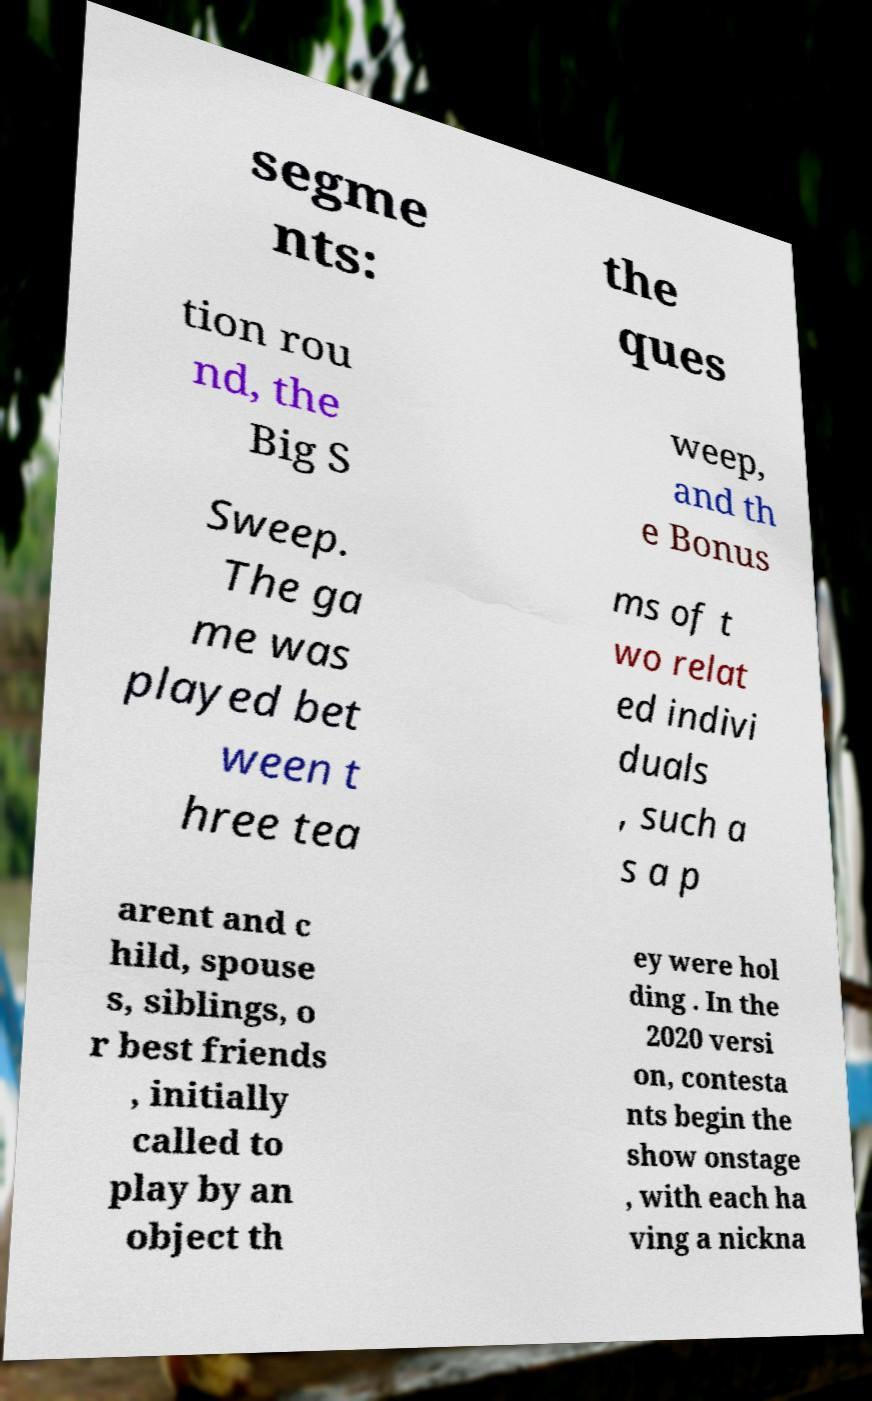Can you accurately transcribe the text from the provided image for me? segme nts: the ques tion rou nd, the Big S weep, and th e Bonus Sweep. The ga me was played bet ween t hree tea ms of t wo relat ed indivi duals , such a s a p arent and c hild, spouse s, siblings, o r best friends , initially called to play by an object th ey were hol ding . In the 2020 versi on, contesta nts begin the show onstage , with each ha ving a nickna 